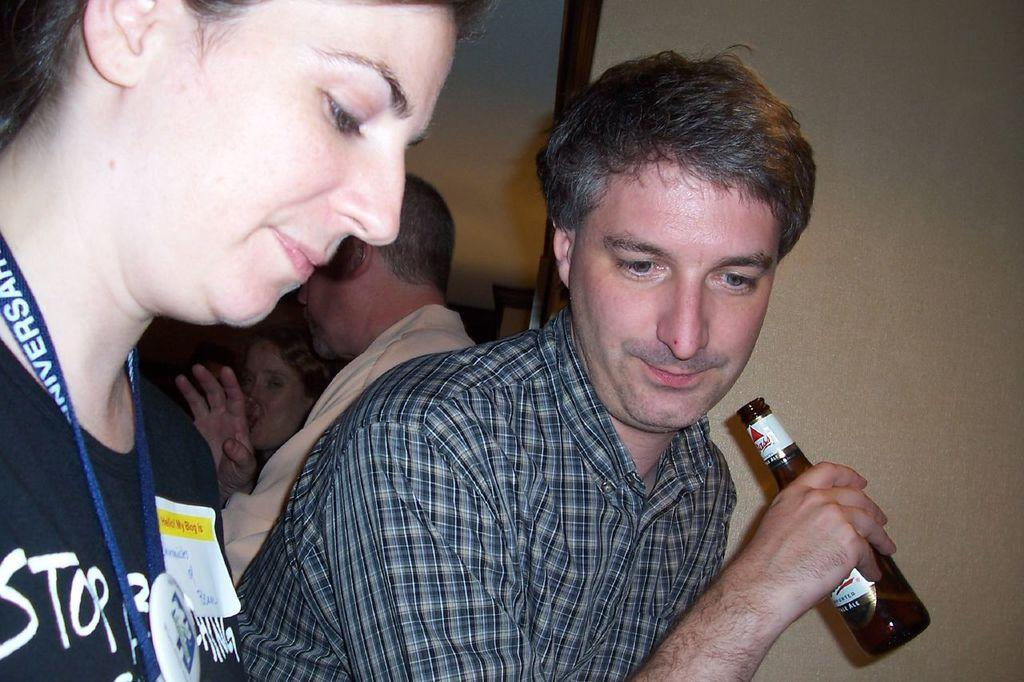What is the man in the image wearing? The man is wearing a check shirt. What is the man holding in the image? The man is holding a bottle. What is the lady in the image wearing? The lady is wearing a tag. How many other persons can be seen in the background of the image? There are other persons in the background of the image. What is visible in the background of the image? There is a wall in the background of the image. How many sheep can be seen grazing in the park in the image? There are no sheep or park present in the image. What is the tendency of the lady in the image to interact with the wall? There is no indication of the lady's tendency to interact with the wall in the image. 